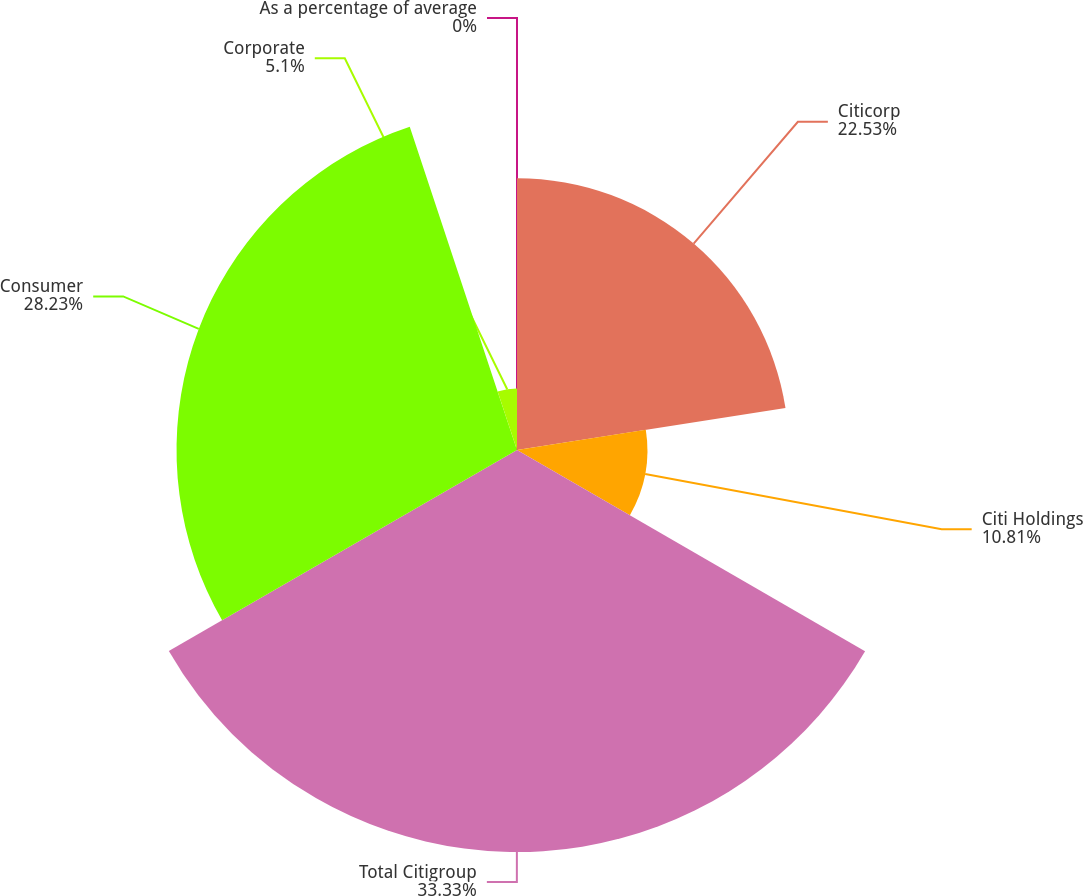Convert chart to OTSL. <chart><loc_0><loc_0><loc_500><loc_500><pie_chart><fcel>As a percentage of average<fcel>Citicorp<fcel>Citi Holdings<fcel>Total Citigroup<fcel>Consumer<fcel>Corporate<nl><fcel>0.0%<fcel>22.53%<fcel>10.81%<fcel>33.33%<fcel>28.23%<fcel>5.1%<nl></chart> 